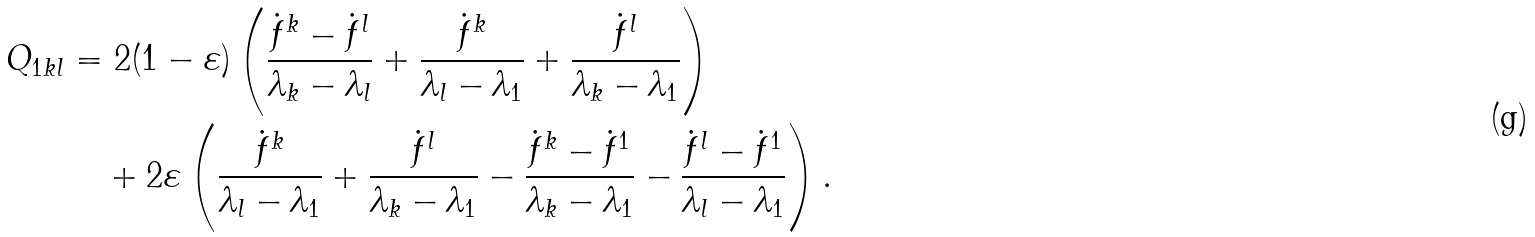<formula> <loc_0><loc_0><loc_500><loc_500>Q _ { 1 k l } & = 2 ( 1 - \varepsilon ) \left ( \frac { \dot { f } ^ { k } - \dot { f } ^ { l } } { \lambda _ { k } - \lambda _ { l } } + \frac { \dot { f } ^ { k } } { \lambda _ { l } - \lambda _ { 1 } } + \frac { \dot { f } ^ { l } } { \lambda _ { k } - \lambda _ { 1 } } \right ) \\ & \quad \null + 2 \varepsilon \left ( \frac { \dot { f } ^ { k } } { \lambda _ { l } - \lambda _ { 1 } } + \frac { \dot { f } ^ { l } } { \lambda _ { k } - \lambda _ { 1 } } - \frac { \dot { f } ^ { k } - \dot { f } ^ { 1 } } { \lambda _ { k } - \lambda _ { 1 } } - \frac { \dot { f } ^ { l } - \dot { f } ^ { 1 } } { \lambda _ { l } - \lambda _ { 1 } } \right ) .</formula> 